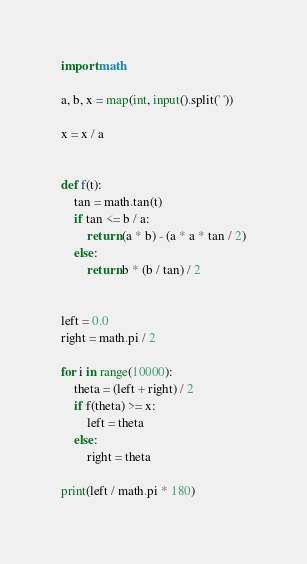Convert code to text. <code><loc_0><loc_0><loc_500><loc_500><_Python_>import math

a, b, x = map(int, input().split(' '))

x = x / a


def f(t):
    tan = math.tan(t)
    if tan <= b / a:
        return (a * b) - (a * a * tan / 2)
    else:
        return b * (b / tan) / 2


left = 0.0
right = math.pi / 2

for i in range(10000):
    theta = (left + right) / 2
    if f(theta) >= x:
        left = theta
    else:
        right = theta

print(left / math.pi * 180)
</code> 